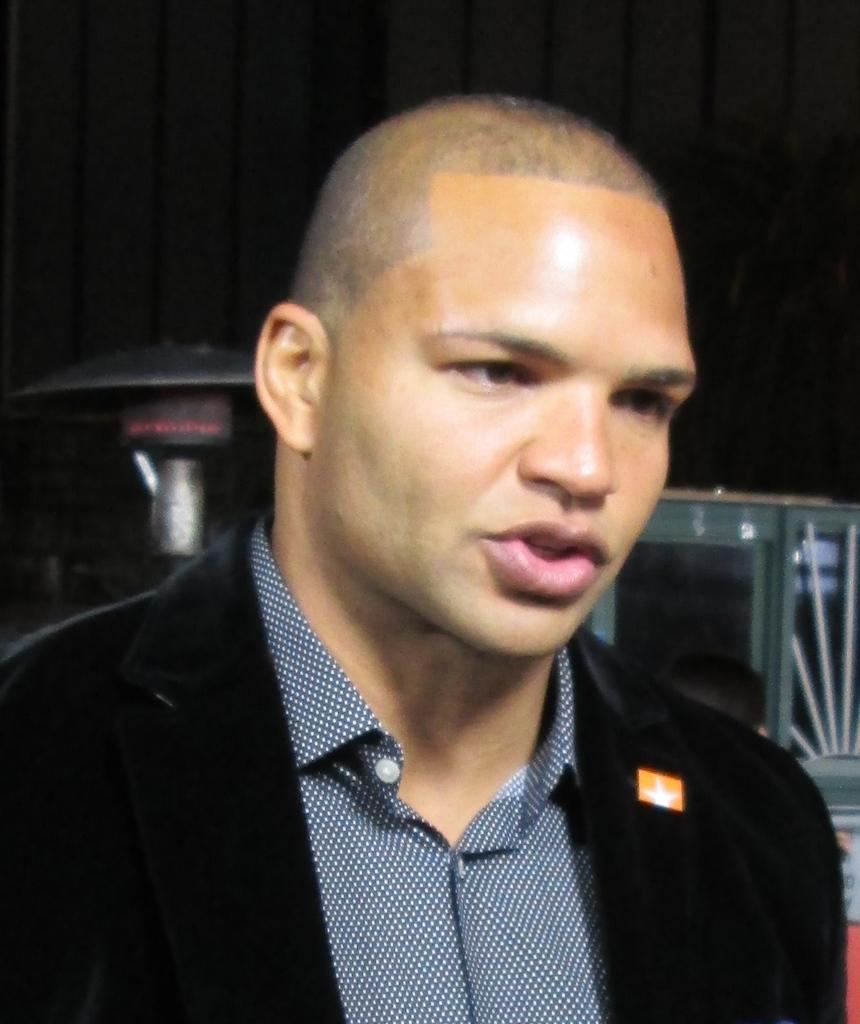Could you give a brief overview of what you see in this image? This is a zoomed in picture. In the foreground there is a person wearing black color blazer and seems to be talking. In the background we can see some metal objects and the background of the image is dark. 